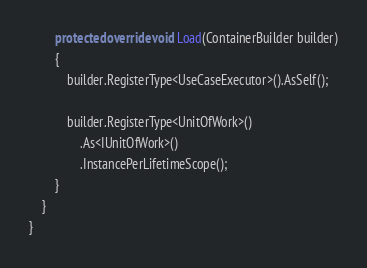Convert code to text. <code><loc_0><loc_0><loc_500><loc_500><_C#_>        protected override void Load(ContainerBuilder builder)
        {
            builder.RegisterType<UseCaseExecutor>().AsSelf();

            builder.RegisterType<UnitOfWork>()
                .As<IUnitOfWork>()
                .InstancePerLifetimeScope();
        }
    }
}
</code> 